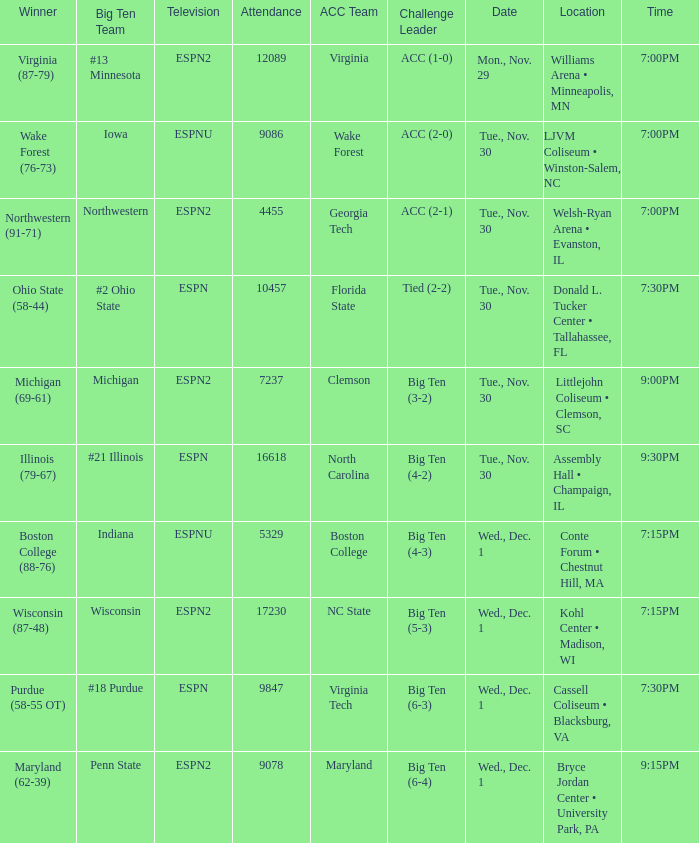Where did the games that had Wake Forest as Acc Team take place? LJVM Coliseum • Winston-Salem, NC. 